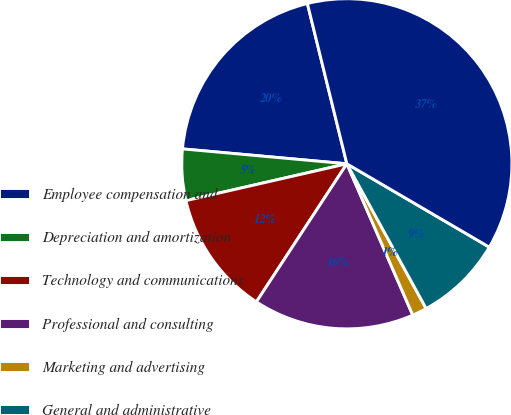Convert chart. <chart><loc_0><loc_0><loc_500><loc_500><pie_chart><fcel>Employee compensation and<fcel>Depreciation and amortization<fcel>Technology and communications<fcel>Professional and consulting<fcel>Marketing and advertising<fcel>General and administrative<fcel>Total expenses<nl><fcel>19.72%<fcel>5.02%<fcel>12.19%<fcel>15.77%<fcel>1.44%<fcel>8.6%<fcel>37.27%<nl></chart> 